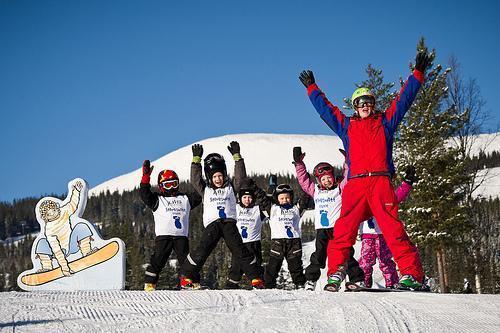How many signs?
Give a very brief answer. 1. 